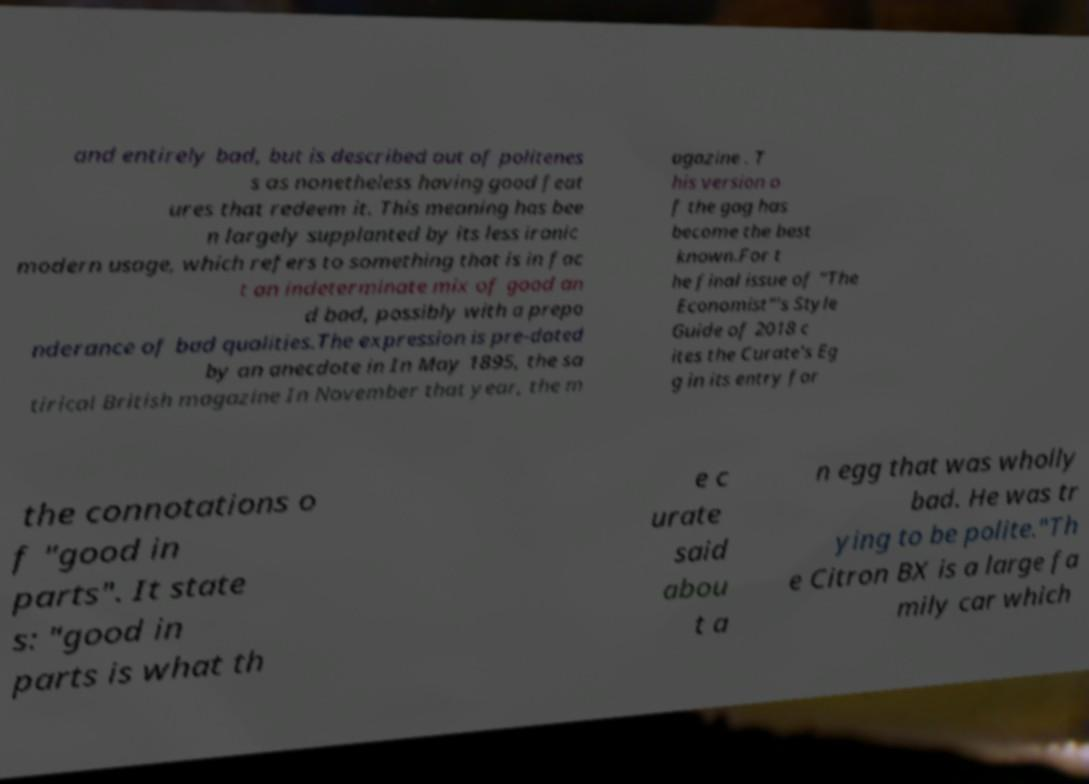There's text embedded in this image that I need extracted. Can you transcribe it verbatim? and entirely bad, but is described out of politenes s as nonetheless having good feat ures that redeem it. This meaning has bee n largely supplanted by its less ironic modern usage, which refers to something that is in fac t an indeterminate mix of good an d bad, possibly with a prepo nderance of bad qualities.The expression is pre-dated by an anecdote in In May 1895, the sa tirical British magazine In November that year, the m agazine . T his version o f the gag has become the best known.For t he final issue of "The Economist"'s Style Guide of 2018 c ites the Curate's Eg g in its entry for the connotations o f "good in parts". It state s: "good in parts is what th e c urate said abou t a n egg that was wholly bad. He was tr ying to be polite."Th e Citron BX is a large fa mily car which 